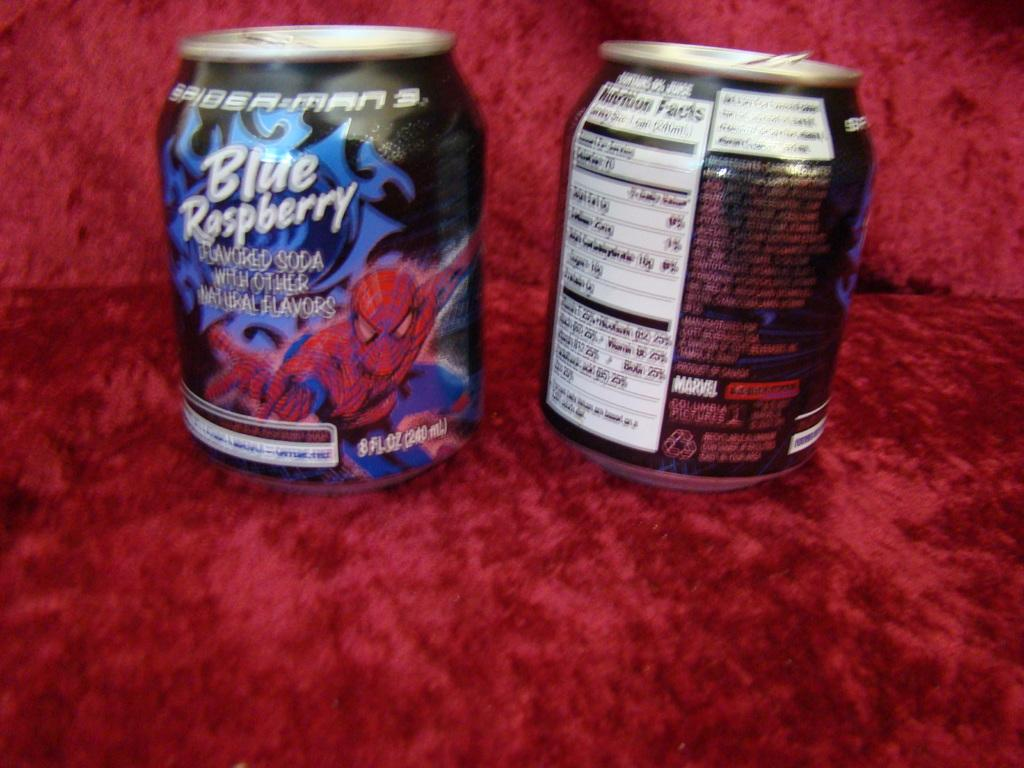<image>
Create a compact narrative representing the image presented. Two blurry cans of Blue Raspberry soda with spiderman on the can. 